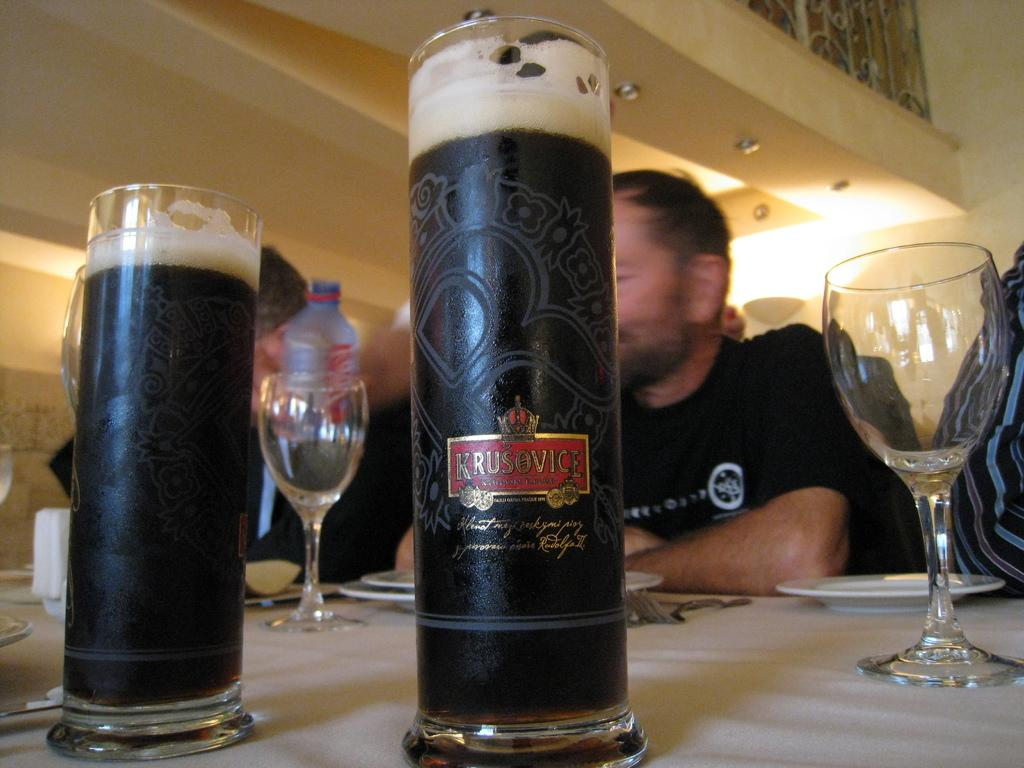What objects are present in the image that people might use for drinking? There are glasses in the image that people might use for drinking. Can you describe the people in the image? There are people in the image, but their specific characteristics are not mentioned in the provided facts. What is on the table in the image? There are plates on a table in the image. How many spoons are on fire in the image? There are no spoons or fire present in the image. What type of cork can be seen in the image? There is no cork present in the image. 